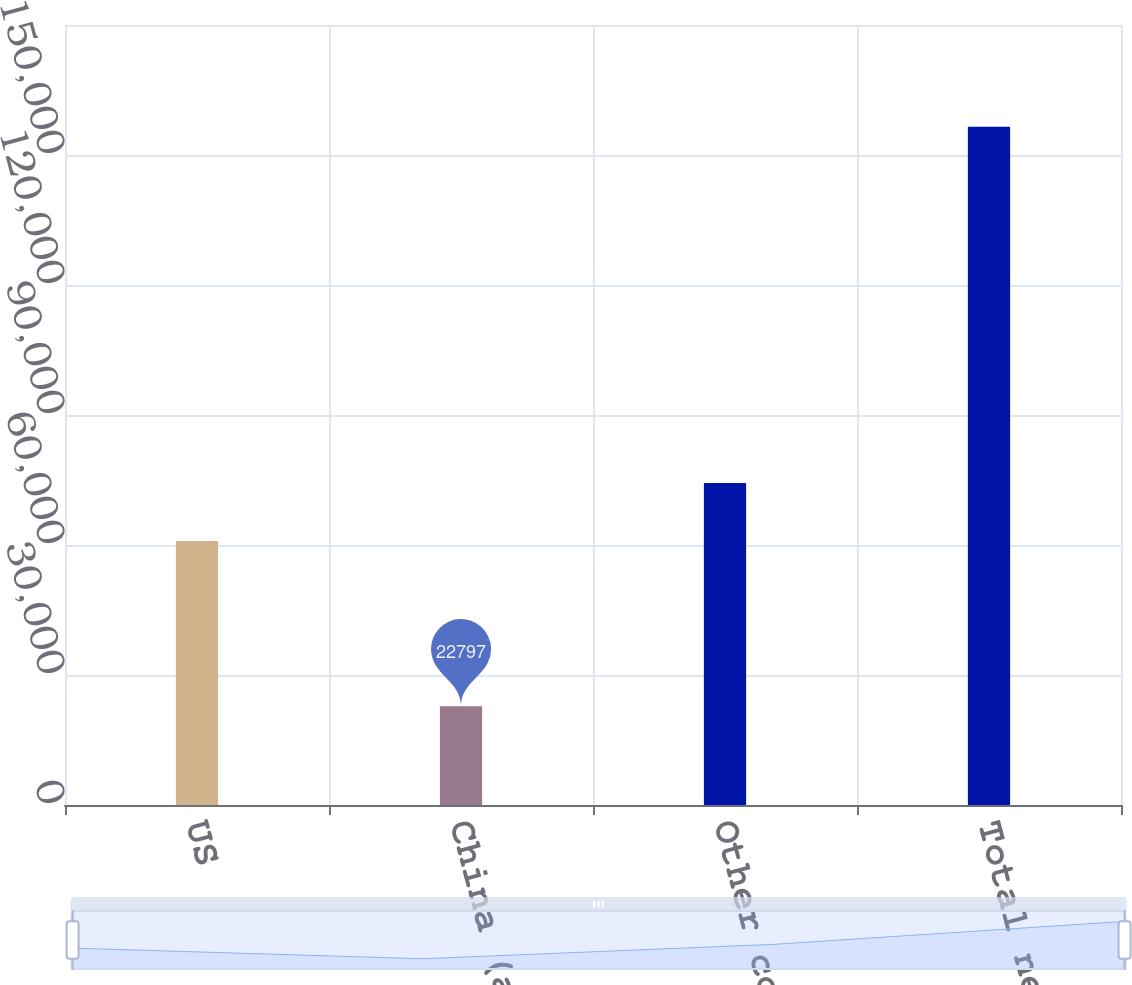<chart> <loc_0><loc_0><loc_500><loc_500><bar_chart><fcel>US<fcel>China (a)<fcel>Other countries<fcel>Total net sales<nl><fcel>60949<fcel>22797<fcel>74320.1<fcel>156508<nl></chart> 